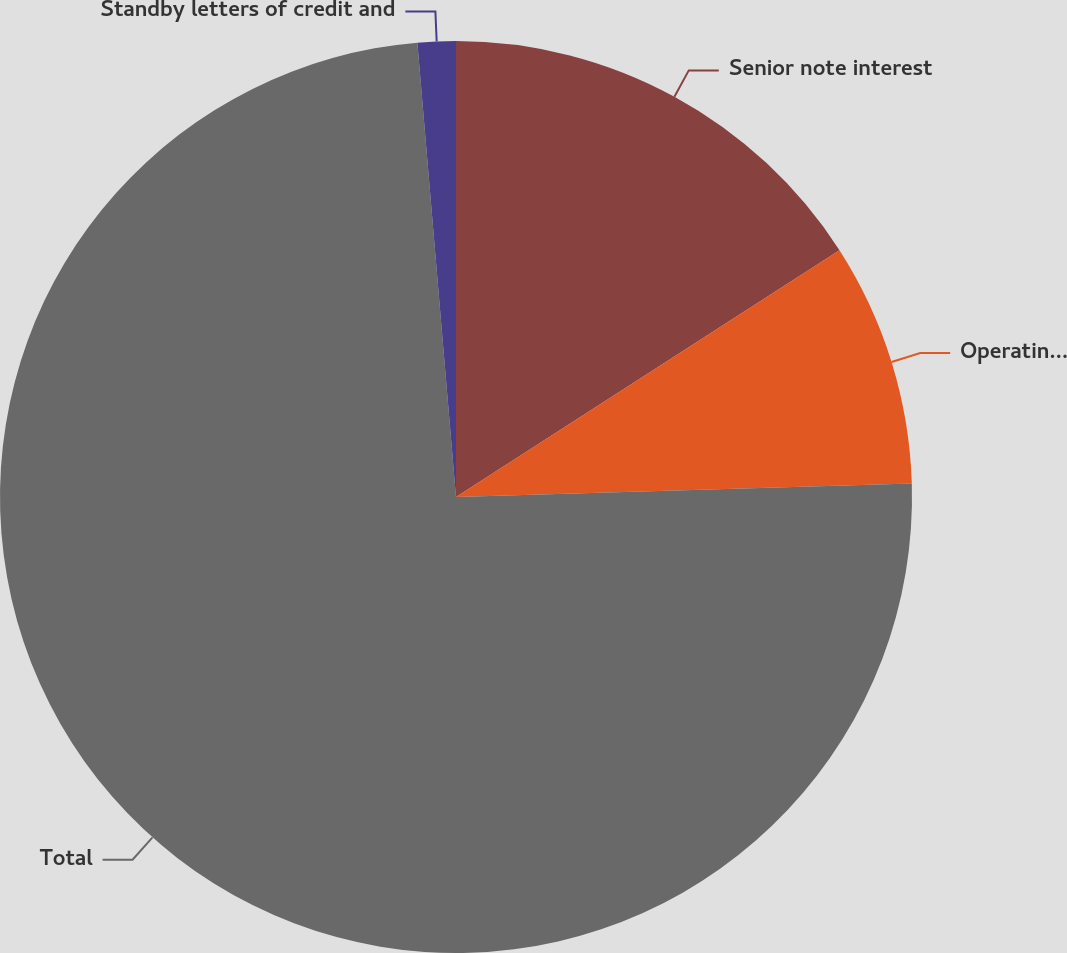Convert chart to OTSL. <chart><loc_0><loc_0><loc_500><loc_500><pie_chart><fcel>Senior note interest<fcel>Operating leases<fcel>Total<fcel>Standby letters of credit and<nl><fcel>15.9%<fcel>8.63%<fcel>74.12%<fcel>1.35%<nl></chart> 